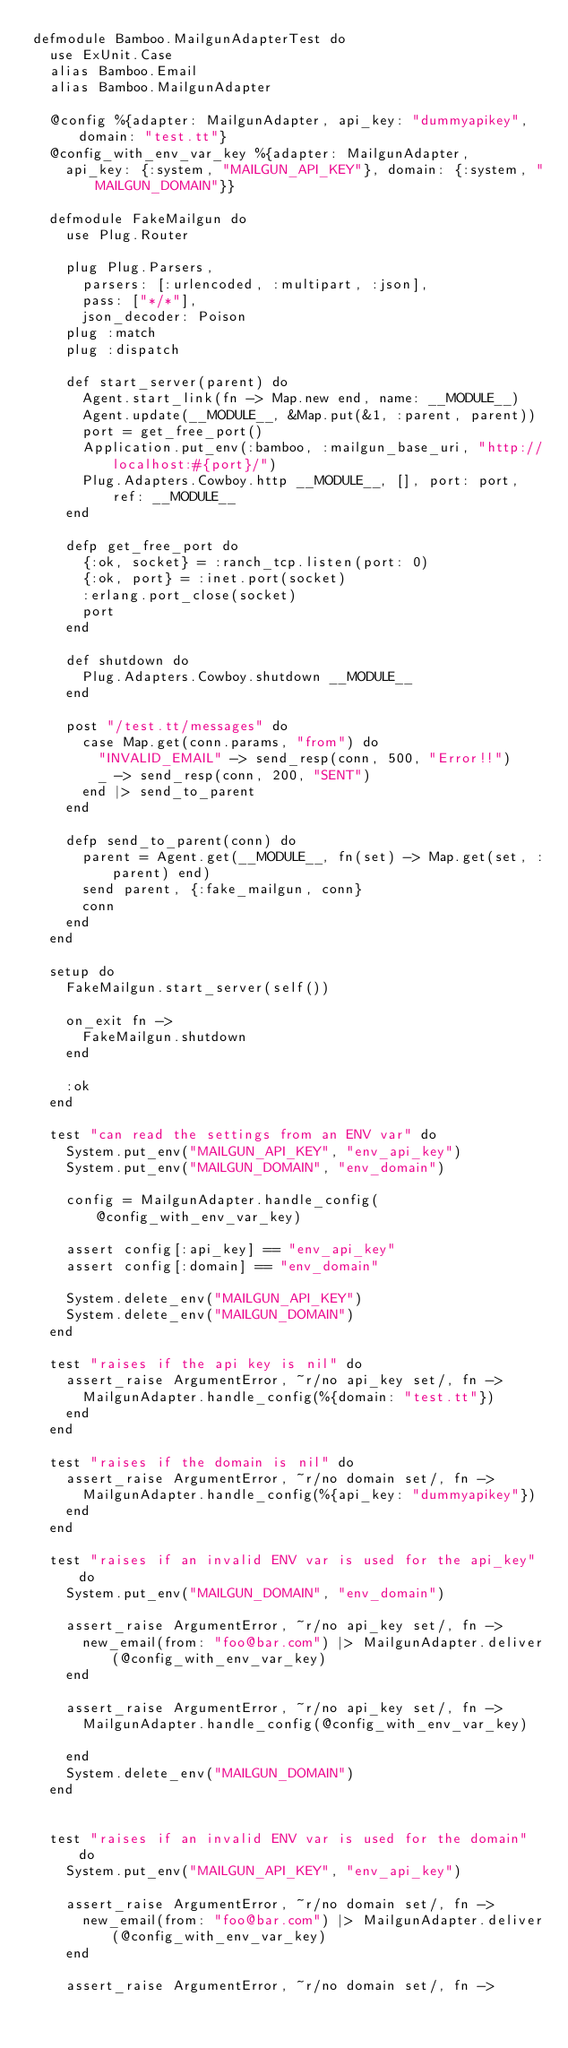Convert code to text. <code><loc_0><loc_0><loc_500><loc_500><_Elixir_>defmodule Bamboo.MailgunAdapterTest do
  use ExUnit.Case
  alias Bamboo.Email
  alias Bamboo.MailgunAdapter

  @config %{adapter: MailgunAdapter, api_key: "dummyapikey", domain: "test.tt"}
  @config_with_env_var_key %{adapter: MailgunAdapter,
    api_key: {:system, "MAILGUN_API_KEY"}, domain: {:system, "MAILGUN_DOMAIN"}}

  defmodule FakeMailgun do
    use Plug.Router

    plug Plug.Parsers,
      parsers: [:urlencoded, :multipart, :json],
      pass: ["*/*"],
      json_decoder: Poison
    plug :match
    plug :dispatch

    def start_server(parent) do
      Agent.start_link(fn -> Map.new end, name: __MODULE__)
      Agent.update(__MODULE__, &Map.put(&1, :parent, parent))
      port = get_free_port()
      Application.put_env(:bamboo, :mailgun_base_uri, "http://localhost:#{port}/")
      Plug.Adapters.Cowboy.http __MODULE__, [], port: port, ref: __MODULE__
    end

    defp get_free_port do
      {:ok, socket} = :ranch_tcp.listen(port: 0)
      {:ok, port} = :inet.port(socket)
      :erlang.port_close(socket)
      port
    end

    def shutdown do
      Plug.Adapters.Cowboy.shutdown __MODULE__
    end

    post "/test.tt/messages" do
      case Map.get(conn.params, "from") do
        "INVALID_EMAIL" -> send_resp(conn, 500, "Error!!")
        _ -> send_resp(conn, 200, "SENT")
      end |> send_to_parent
    end

    defp send_to_parent(conn) do
      parent = Agent.get(__MODULE__, fn(set) -> Map.get(set, :parent) end)
      send parent, {:fake_mailgun, conn}
      conn
    end
  end

  setup do
    FakeMailgun.start_server(self())

    on_exit fn ->
      FakeMailgun.shutdown
    end

    :ok
  end

  test "can read the settings from an ENV var" do
    System.put_env("MAILGUN_API_KEY", "env_api_key")
    System.put_env("MAILGUN_DOMAIN", "env_domain")

    config = MailgunAdapter.handle_config(@config_with_env_var_key)

    assert config[:api_key] == "env_api_key"
    assert config[:domain] == "env_domain"

    System.delete_env("MAILGUN_API_KEY")
    System.delete_env("MAILGUN_DOMAIN")
  end

  test "raises if the api key is nil" do
    assert_raise ArgumentError, ~r/no api_key set/, fn ->
      MailgunAdapter.handle_config(%{domain: "test.tt"})
    end
  end

  test "raises if the domain is nil" do
    assert_raise ArgumentError, ~r/no domain set/, fn ->
      MailgunAdapter.handle_config(%{api_key: "dummyapikey"})
    end
  end

  test "raises if an invalid ENV var is used for the api_key" do
    System.put_env("MAILGUN_DOMAIN", "env_domain")

    assert_raise ArgumentError, ~r/no api_key set/, fn ->
      new_email(from: "foo@bar.com") |> MailgunAdapter.deliver(@config_with_env_var_key)
    end

    assert_raise ArgumentError, ~r/no api_key set/, fn ->
      MailgunAdapter.handle_config(@config_with_env_var_key)

    end
    System.delete_env("MAILGUN_DOMAIN")
  end


  test "raises if an invalid ENV var is used for the domain" do
    System.put_env("MAILGUN_API_KEY", "env_api_key")

    assert_raise ArgumentError, ~r/no domain set/, fn ->
      new_email(from: "foo@bar.com") |> MailgunAdapter.deliver(@config_with_env_var_key)
    end

    assert_raise ArgumentError, ~r/no domain set/, fn -></code> 